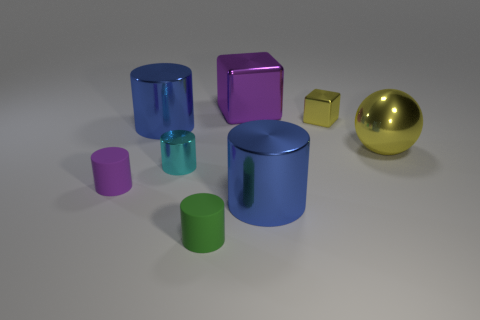Is the color of the big sphere the same as the small metallic cube?
Ensure brevity in your answer.  Yes. What is the material of the tiny purple cylinder on the left side of the blue metal cylinder that is in front of the large metallic cylinder behind the big metallic sphere?
Ensure brevity in your answer.  Rubber. Is the number of metallic cubes that are left of the yellow metal sphere greater than the number of small green matte objects behind the purple block?
Give a very brief answer. Yes. Is the size of the cyan cylinder the same as the metallic ball?
Ensure brevity in your answer.  No. What color is the other rubber thing that is the same shape as the small green rubber object?
Your answer should be very brief. Purple. What number of large spheres are the same color as the tiny metal cube?
Your answer should be very brief. 1. Is the number of yellow shiny cubes behind the tiny cyan cylinder greater than the number of large red shiny spheres?
Provide a succinct answer. Yes. What is the color of the big shiny cylinder that is behind the big yellow object right of the green rubber object?
Provide a succinct answer. Blue. What number of objects are either blue cylinders that are in front of the cyan shiny thing or small objects that are behind the green thing?
Your answer should be very brief. 4. The ball has what color?
Provide a short and direct response. Yellow. 